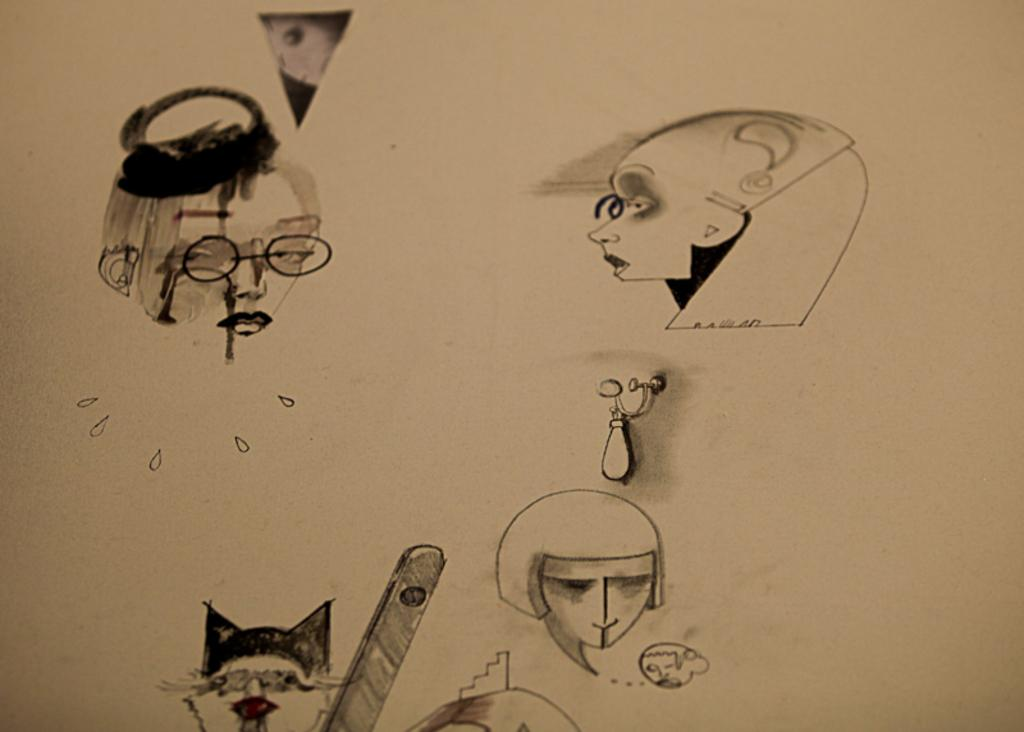What type of drawings are present in the image? The image contains sketches of people and objects. What color is the background of the image? The background of the image is cream-colored. What type of hope can be seen in the image? There is no hope present in the image, as it contains sketches of people and objects, not emotions or abstract concepts. 